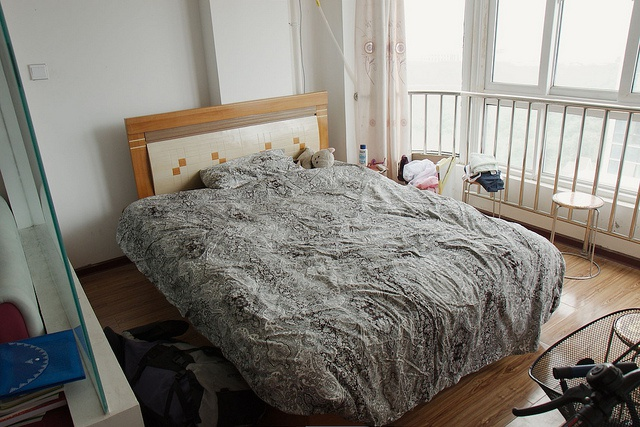Describe the objects in this image and their specific colors. I can see bed in darkgray, gray, and black tones, bicycle in darkgray, black, and gray tones, and teddy bear in darkgray and gray tones in this image. 